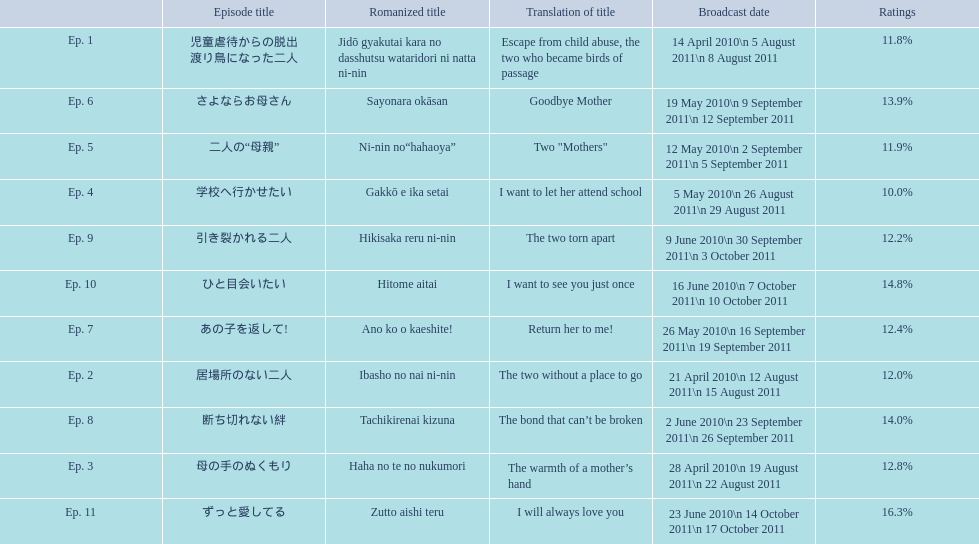What are the episode numbers? Ep. 1, Ep. 2, Ep. 3, Ep. 4, Ep. 5, Ep. 6, Ep. 7, Ep. 8, Ep. 9, Ep. 10, Ep. 11. What was the percentage of total ratings for episode 8? 14.0%. 